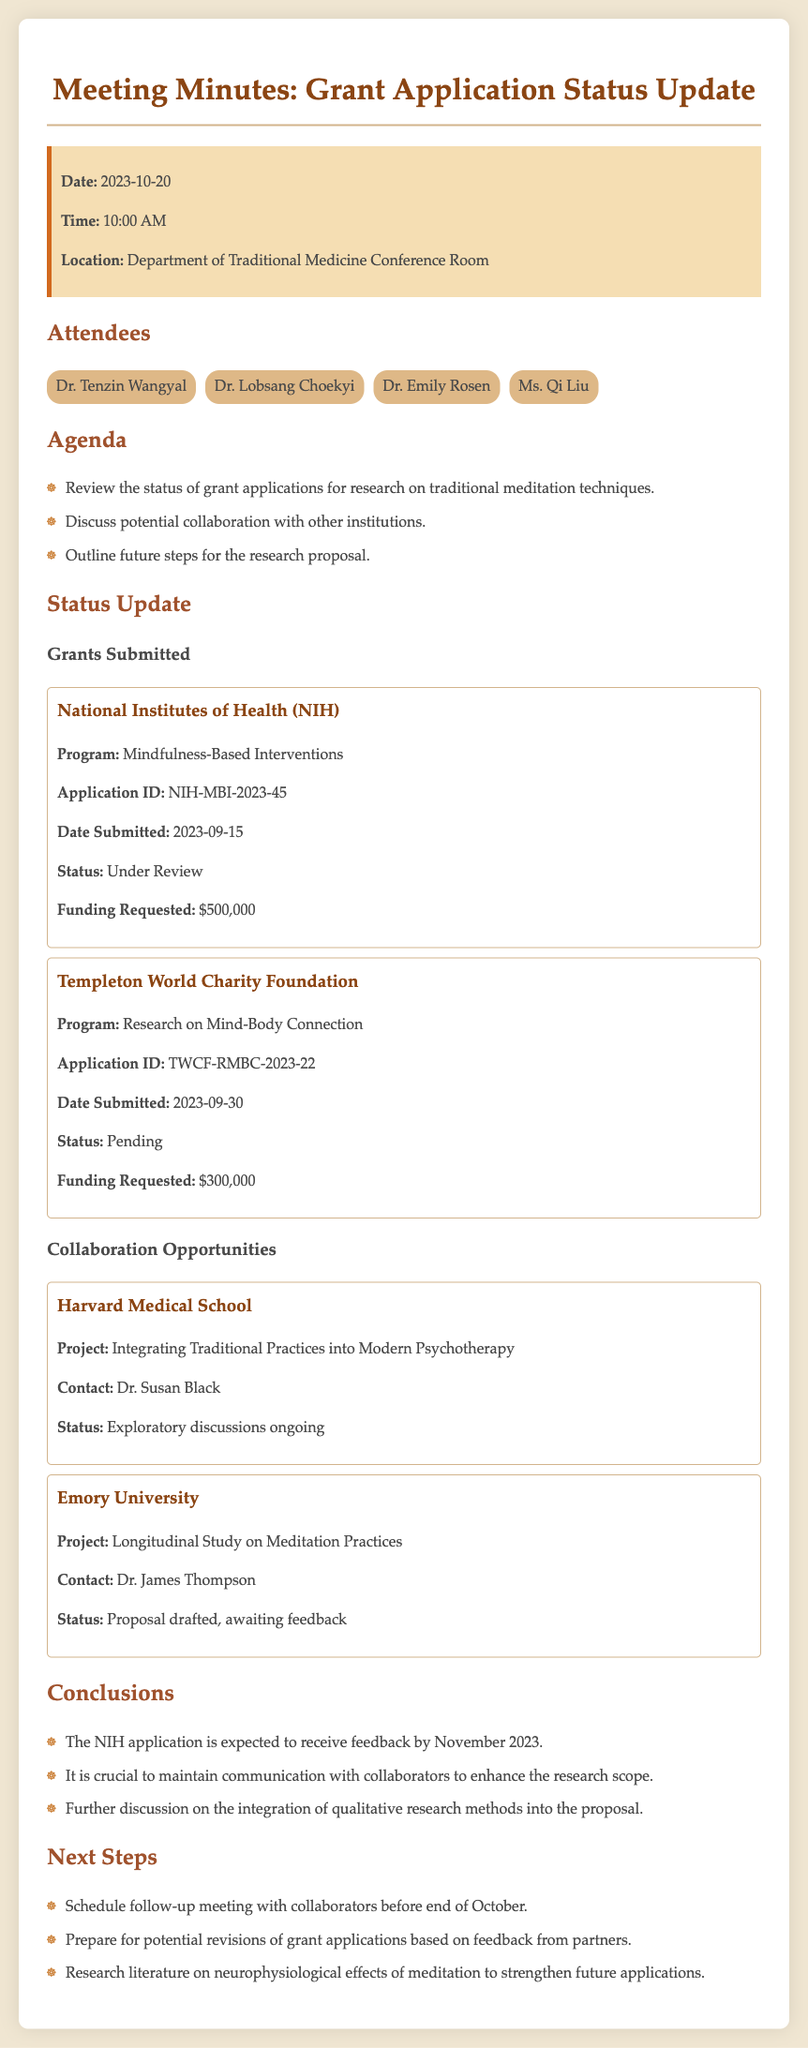What is the date of the meeting? The date of the meeting is stated in the info box at the beginning of the document.
Answer: 2023-10-20 What is the funding requested for the NIH application? The funding requested for the NIH application is specified within the grant status section for NIH.
Answer: $500,000 Who is the contact person for the project with Harvard Medical School? The contact person for the Harvard Medical School project can be found under the collaboration opportunities section.
Answer: Dr. Susan Black What is the status of the Templeton World Charity Foundation application? The status for the Templeton World Charity Foundation application is mentioned in the grant status section.
Answer: Pending When was the NIH application submitted? The submission date of the NIH application is indicated in the grant status section.
Answer: 2023-09-15 What future action is mentioned regarding communication with collaborators? Future actions regarding collaborators are outlined in the conclusions section and specifically mention maintaining communication.
Answer: Crucial to maintain communication How many grant applications are currently under review? The document states the status of grant applications, highlighting one under review.
Answer: One What is the status of the Emory University project proposal? The status of the Emory University project can be found under the collaboration opportunities section.
Answer: Proposal drafted, awaiting feedback How much funding is requested from the Templeton World Charity Foundation? The requested funding from the Templeton World Charity Foundation is detailed in the grant status section.
Answer: $300,000 